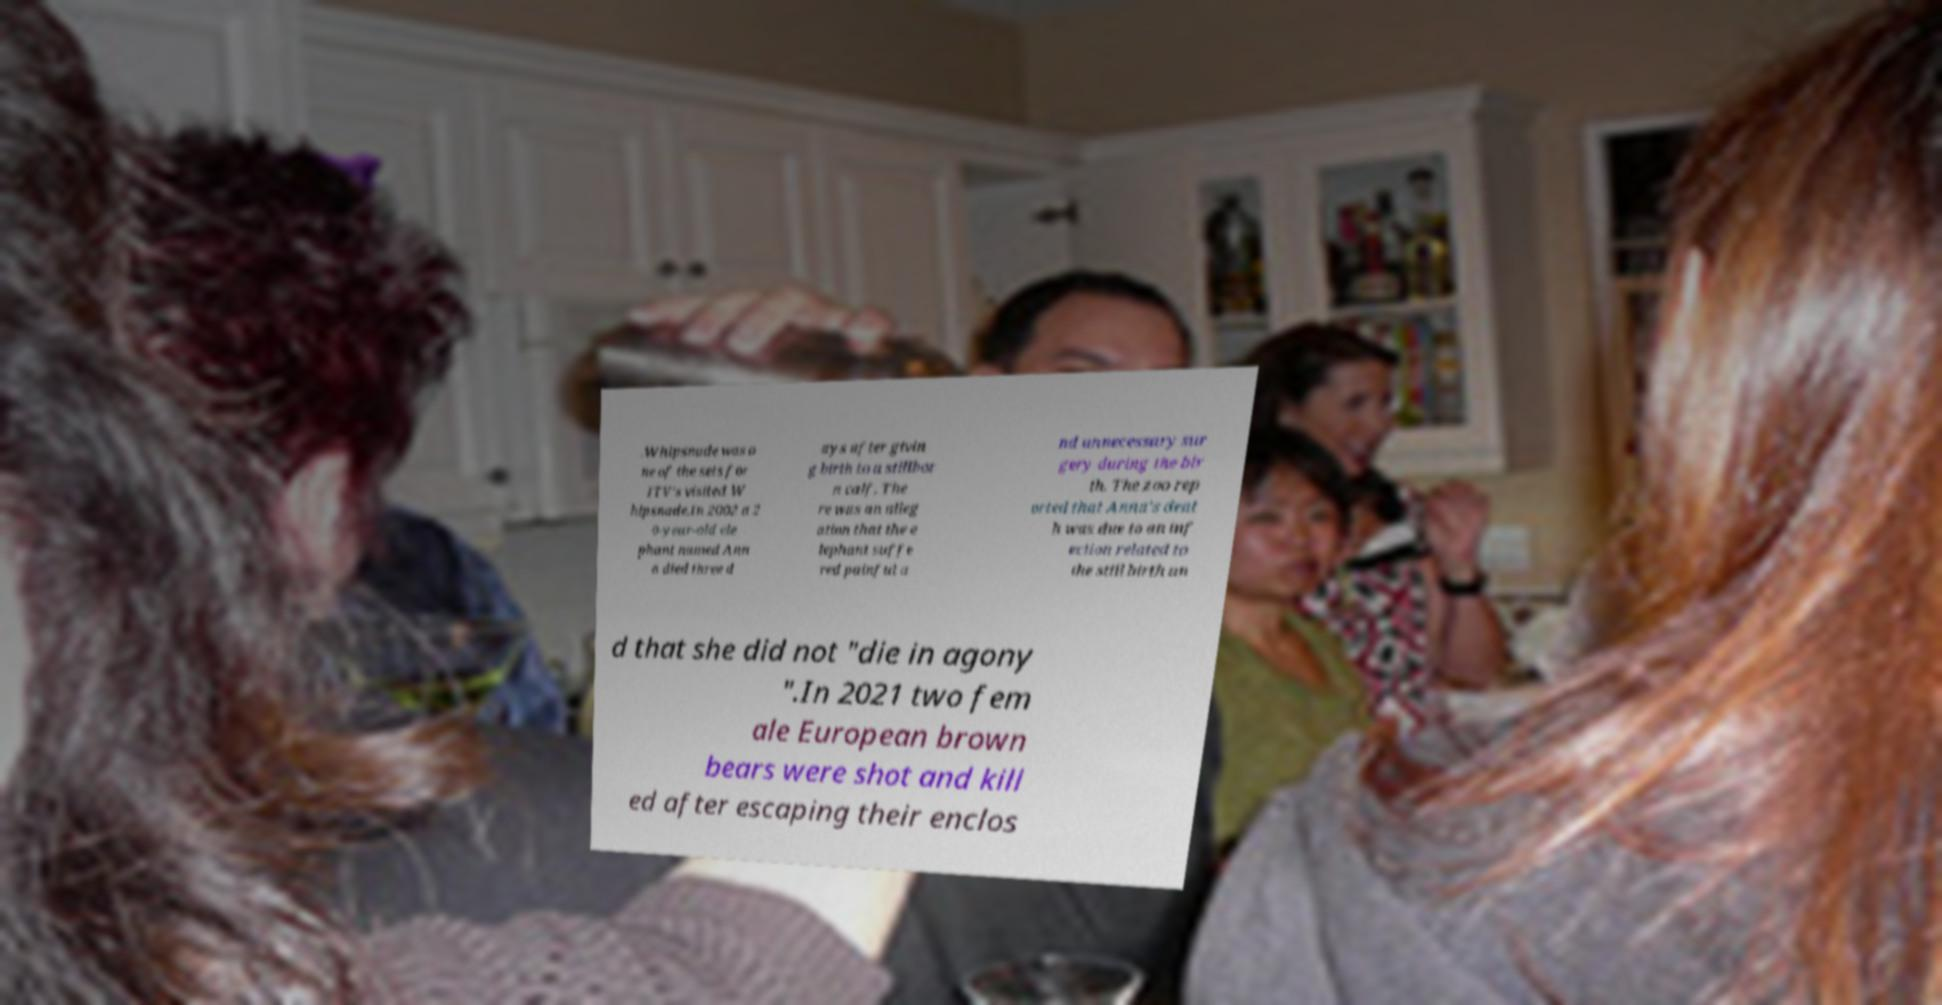Could you assist in decoding the text presented in this image and type it out clearly? .Whipsnade was o ne of the sets for ITV's visited W hipsnade.In 2002 a 2 0-year-old ele phant named Ann a died three d ays after givin g birth to a stillbor n calf. The re was an alleg ation that the e lephant suffe red painful a nd unnecessary sur gery during the bir th. The zoo rep orted that Anna's deat h was due to an inf ection related to the still birth an d that she did not "die in agony ".In 2021 two fem ale European brown bears were shot and kill ed after escaping their enclos 